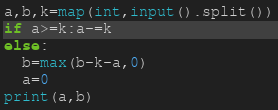Convert code to text. <code><loc_0><loc_0><loc_500><loc_500><_Python_>a,b,k=map(int,input().split())
if a>=k:a-=k
else:
  b=max(b-k-a,0)
  a=0
print(a,b)</code> 